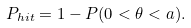Convert formula to latex. <formula><loc_0><loc_0><loc_500><loc_500>P _ { h i t } = 1 - P ( 0 < \theta < a ) .</formula> 